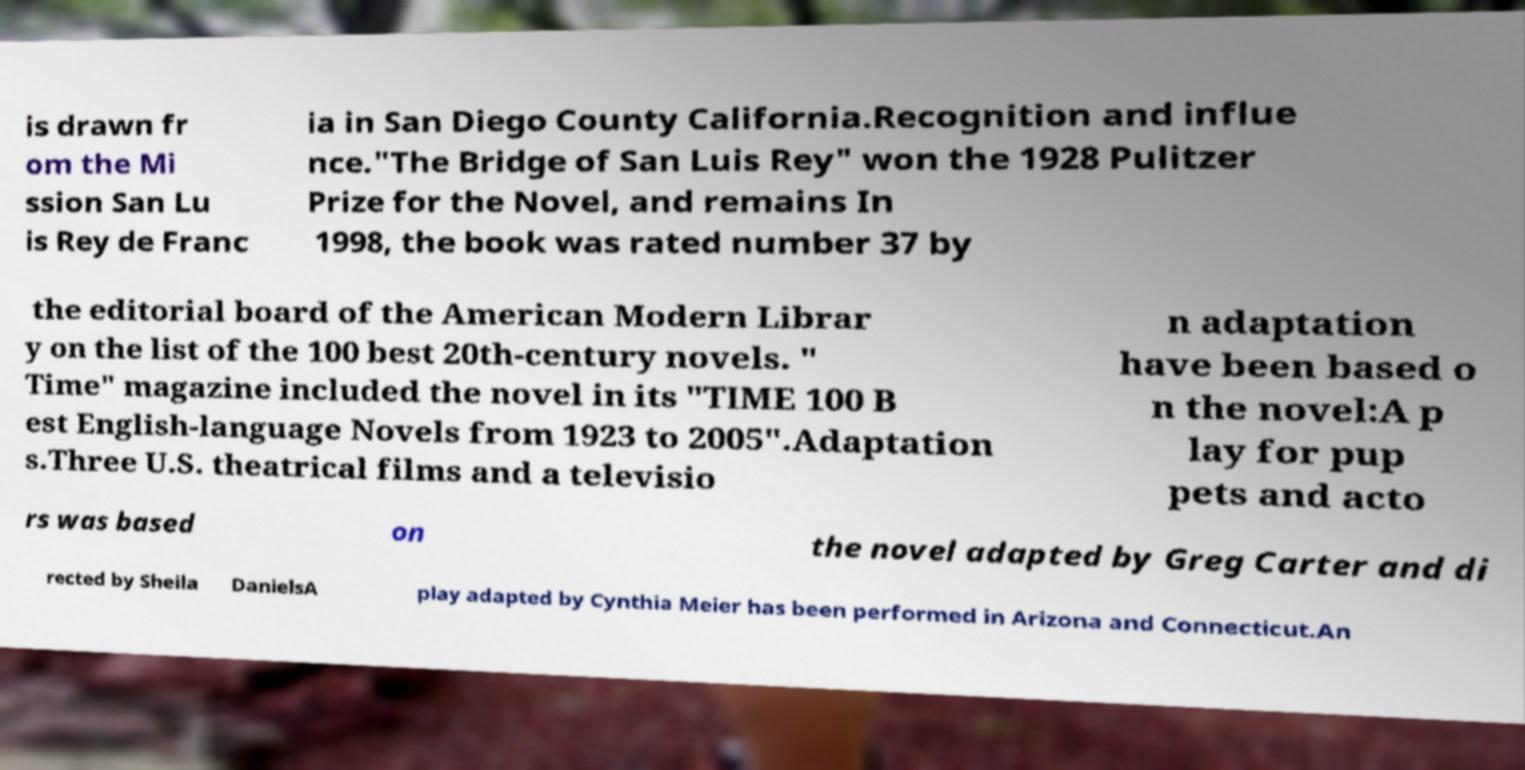Could you assist in decoding the text presented in this image and type it out clearly? is drawn fr om the Mi ssion San Lu is Rey de Franc ia in San Diego County California.Recognition and influe nce."The Bridge of San Luis Rey" won the 1928 Pulitzer Prize for the Novel, and remains In 1998, the book was rated number 37 by the editorial board of the American Modern Librar y on the list of the 100 best 20th-century novels. " Time" magazine included the novel in its "TIME 100 B est English-language Novels from 1923 to 2005".Adaptation s.Three U.S. theatrical films and a televisio n adaptation have been based o n the novel:A p lay for pup pets and acto rs was based on the novel adapted by Greg Carter and di rected by Sheila DanielsA play adapted by Cynthia Meier has been performed in Arizona and Connecticut.An 